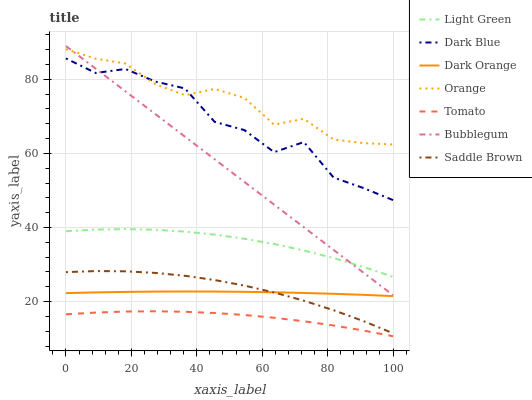Does Dark Orange have the minimum area under the curve?
Answer yes or no. No. Does Dark Orange have the maximum area under the curve?
Answer yes or no. No. Is Dark Orange the smoothest?
Answer yes or no. No. Is Dark Orange the roughest?
Answer yes or no. No. Does Dark Orange have the lowest value?
Answer yes or no. No. Does Dark Orange have the highest value?
Answer yes or no. No. Is Tomato less than Bubblegum?
Answer yes or no. Yes. Is Light Green greater than Saddle Brown?
Answer yes or no. Yes. Does Tomato intersect Bubblegum?
Answer yes or no. No. 